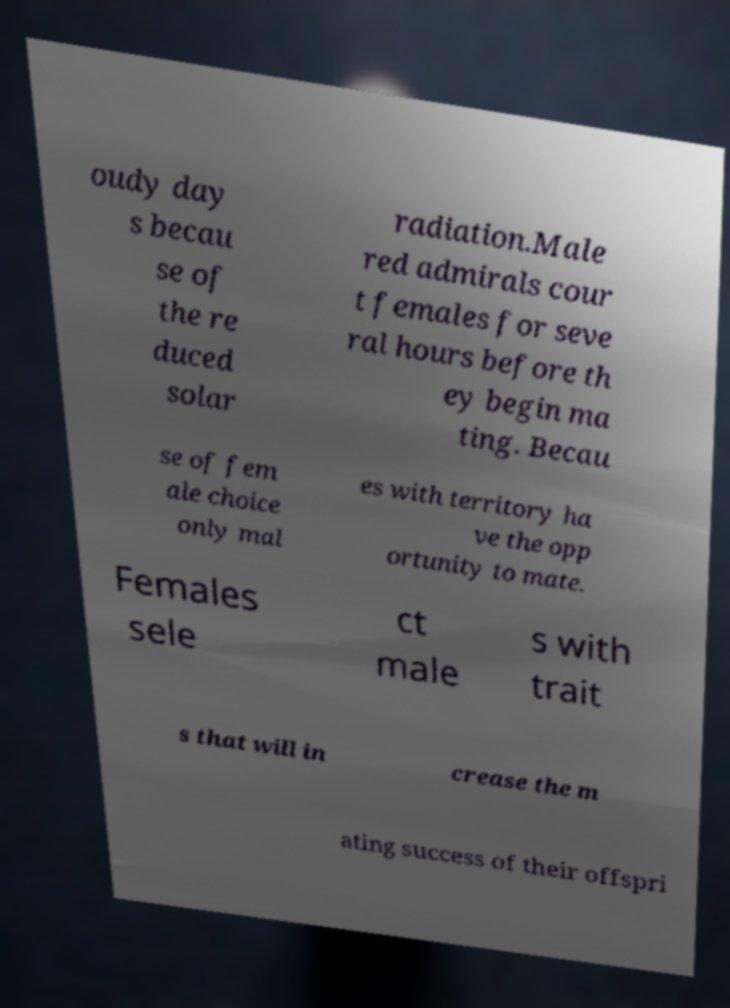What messages or text are displayed in this image? I need them in a readable, typed format. oudy day s becau se of the re duced solar radiation.Male red admirals cour t females for seve ral hours before th ey begin ma ting. Becau se of fem ale choice only mal es with territory ha ve the opp ortunity to mate. Females sele ct male s with trait s that will in crease the m ating success of their offspri 